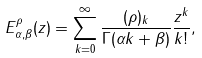<formula> <loc_0><loc_0><loc_500><loc_500>E _ { \alpha , \beta } ^ { \rho } ( z ) = \sum _ { k = 0 } ^ { \infty } \frac { ( \rho ) _ { k } } { \Gamma ( \alpha k + \beta ) } \frac { z ^ { k } } { k ! } ,</formula> 